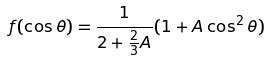Convert formula to latex. <formula><loc_0><loc_0><loc_500><loc_500>f ( \cos \theta ) = \frac { 1 } { 2 + \frac { 2 } { 3 } A } ( 1 + A \cos ^ { 2 } \theta )</formula> 